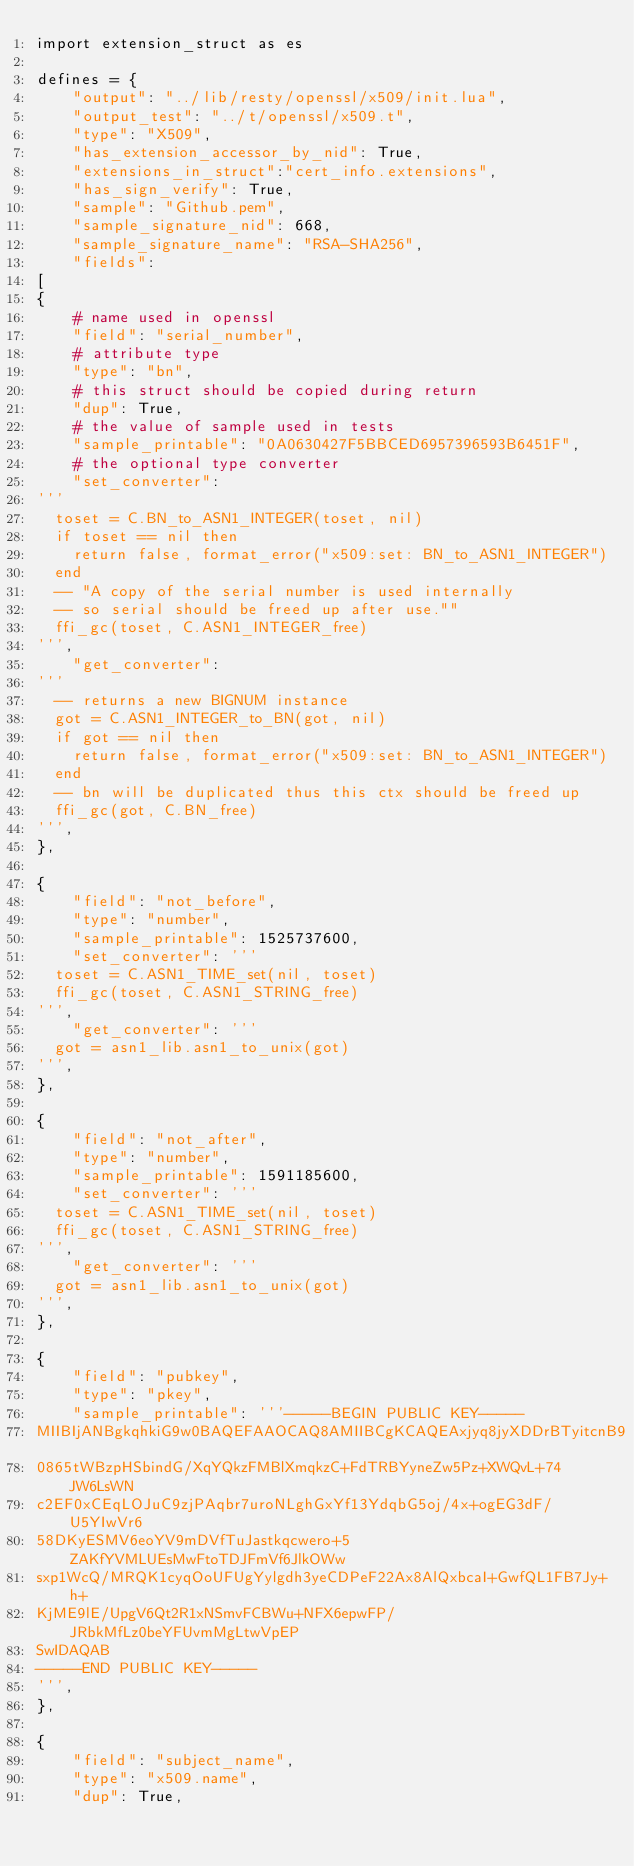<code> <loc_0><loc_0><loc_500><loc_500><_Python_>import extension_struct as es

defines = {
    "output": "../lib/resty/openssl/x509/init.lua",
    "output_test": "../t/openssl/x509.t",
    "type": "X509",
    "has_extension_accessor_by_nid": True,
    "extensions_in_struct":"cert_info.extensions",
    "has_sign_verify": True,
    "sample": "Github.pem",
    "sample_signature_nid": 668,
    "sample_signature_name": "RSA-SHA256",
    "fields":
[
{
    # name used in openssl
    "field": "serial_number",
    # attribute type
    "type": "bn",
    # this struct should be copied during return
    "dup": True,
    # the value of sample used in tests
    "sample_printable": "0A0630427F5BBCED6957396593B6451F",
    # the optional type converter
    "set_converter":
'''
  toset = C.BN_to_ASN1_INTEGER(toset, nil)
  if toset == nil then
    return false, format_error("x509:set: BN_to_ASN1_INTEGER")
  end
  -- "A copy of the serial number is used internally
  -- so serial should be freed up after use.""
  ffi_gc(toset, C.ASN1_INTEGER_free)
''',
    "get_converter":
'''
  -- returns a new BIGNUM instance
  got = C.ASN1_INTEGER_to_BN(got, nil)
  if got == nil then
    return false, format_error("x509:set: BN_to_ASN1_INTEGER")
  end
  -- bn will be duplicated thus this ctx should be freed up
  ffi_gc(got, C.BN_free)
''',
},

{
    "field": "not_before",
    "type": "number",
    "sample_printable": 1525737600,
    "set_converter": '''
  toset = C.ASN1_TIME_set(nil, toset)
  ffi_gc(toset, C.ASN1_STRING_free)
''',
    "get_converter": '''
  got = asn1_lib.asn1_to_unix(got)
''',
},

{
    "field": "not_after",
    "type": "number",
    "sample_printable": 1591185600,
    "set_converter": '''
  toset = C.ASN1_TIME_set(nil, toset)
  ffi_gc(toset, C.ASN1_STRING_free)
''',
    "get_converter": '''
  got = asn1_lib.asn1_to_unix(got)
''',
},

{
    "field": "pubkey",
    "type": "pkey",
    "sample_printable": '''-----BEGIN PUBLIC KEY-----
MIIBIjANBgkqhkiG9w0BAQEFAAOCAQ8AMIIBCgKCAQEAxjyq8jyXDDrBTyitcnB9
0865tWBzpHSbindG/XqYQkzFMBlXmqkzC+FdTRBYyneZw5Pz+XWQvL+74JW6LsWN
c2EF0xCEqLOJuC9zjPAqbr7uroNLghGxYf13YdqbG5oj/4x+ogEG3dF/U5YIwVr6
58DKyESMV6eoYV9mDVfTuJastkqcwero+5ZAKfYVMLUEsMwFtoTDJFmVf6JlkOWw
sxp1WcQ/MRQK1cyqOoUFUgYylgdh3yeCDPeF22Ax8AlQxbcaI+GwfQL1FB7Jy+h+
KjME9lE/UpgV6Qt2R1xNSmvFCBWu+NFX6epwFP/JRbkMfLz0beYFUvmMgLtwVpEP
SwIDAQAB
-----END PUBLIC KEY-----
''',
},

{
    "field": "subject_name",
    "type": "x509.name",
    "dup": True,</code> 